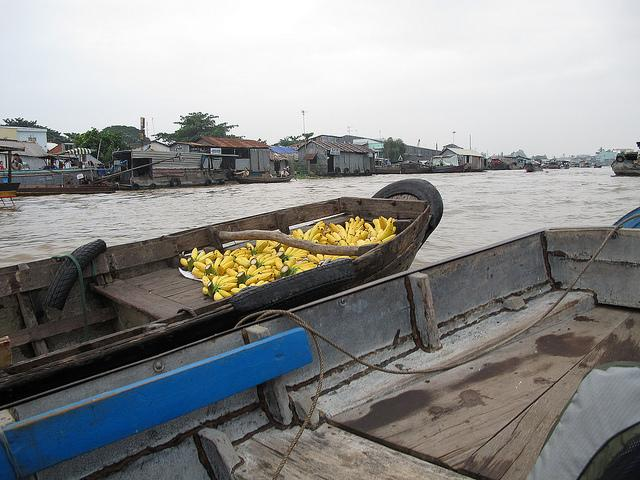What food is on the boat?

Choices:
A) banana
B) apple
C) orange
D) eggplant banana 